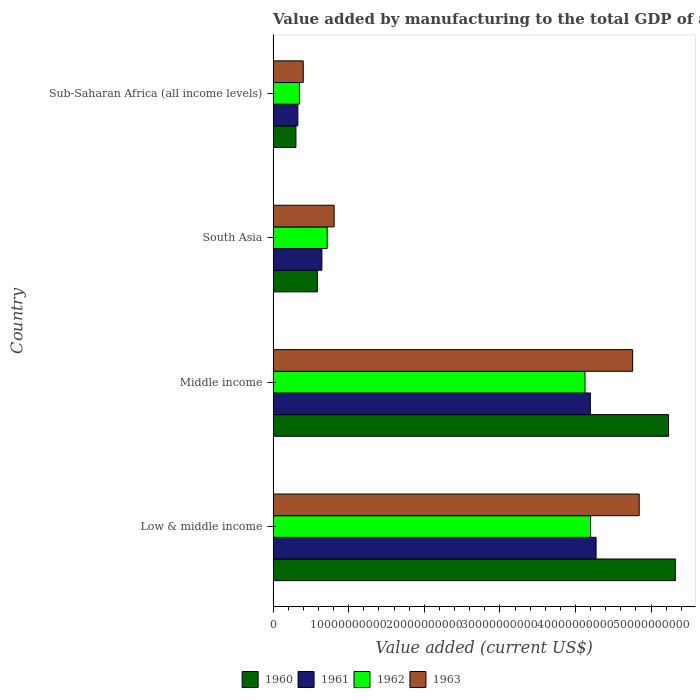How many groups of bars are there?
Offer a very short reply. 4. Are the number of bars on each tick of the Y-axis equal?
Your response must be concise. Yes. How many bars are there on the 4th tick from the bottom?
Your response must be concise. 4. What is the label of the 2nd group of bars from the top?
Your answer should be compact. South Asia. What is the value added by manufacturing to the total GDP in 1962 in Low & middle income?
Give a very brief answer. 4.20e+1. Across all countries, what is the maximum value added by manufacturing to the total GDP in 1961?
Make the answer very short. 4.27e+1. Across all countries, what is the minimum value added by manufacturing to the total GDP in 1962?
Give a very brief answer. 3.48e+09. In which country was the value added by manufacturing to the total GDP in 1960 maximum?
Offer a terse response. Low & middle income. In which country was the value added by manufacturing to the total GDP in 1960 minimum?
Provide a succinct answer. Sub-Saharan Africa (all income levels). What is the total value added by manufacturing to the total GDP in 1962 in the graph?
Provide a short and direct response. 9.39e+1. What is the difference between the value added by manufacturing to the total GDP in 1963 in Low & middle income and that in South Asia?
Your answer should be very brief. 4.04e+1. What is the difference between the value added by manufacturing to the total GDP in 1961 in Middle income and the value added by manufacturing to the total GDP in 1963 in Low & middle income?
Keep it short and to the point. -6.46e+09. What is the average value added by manufacturing to the total GDP in 1962 per country?
Give a very brief answer. 2.35e+1. What is the difference between the value added by manufacturing to the total GDP in 1962 and value added by manufacturing to the total GDP in 1960 in Sub-Saharan Africa (all income levels)?
Ensure brevity in your answer.  4.65e+08. What is the ratio of the value added by manufacturing to the total GDP in 1962 in South Asia to that in Sub-Saharan Africa (all income levels)?
Your answer should be compact. 2.05. Is the value added by manufacturing to the total GDP in 1961 in South Asia less than that in Sub-Saharan Africa (all income levels)?
Make the answer very short. No. What is the difference between the highest and the second highest value added by manufacturing to the total GDP in 1961?
Your answer should be compact. 7.56e+08. What is the difference between the highest and the lowest value added by manufacturing to the total GDP in 1963?
Provide a short and direct response. 4.44e+1. What does the 2nd bar from the top in Low & middle income represents?
Offer a very short reply. 1962. Is it the case that in every country, the sum of the value added by manufacturing to the total GDP in 1960 and value added by manufacturing to the total GDP in 1962 is greater than the value added by manufacturing to the total GDP in 1963?
Provide a succinct answer. Yes. How many bars are there?
Give a very brief answer. 16. Are all the bars in the graph horizontal?
Your answer should be compact. Yes. Where does the legend appear in the graph?
Provide a short and direct response. Bottom center. How are the legend labels stacked?
Your answer should be compact. Horizontal. What is the title of the graph?
Your response must be concise. Value added by manufacturing to the total GDP of a country. Does "1985" appear as one of the legend labels in the graph?
Your answer should be compact. No. What is the label or title of the X-axis?
Give a very brief answer. Value added (current US$). What is the Value added (current US$) in 1960 in Low & middle income?
Offer a very short reply. 5.32e+1. What is the Value added (current US$) in 1961 in Low & middle income?
Provide a short and direct response. 4.27e+1. What is the Value added (current US$) of 1962 in Low & middle income?
Provide a short and direct response. 4.20e+1. What is the Value added (current US$) in 1963 in Low & middle income?
Provide a succinct answer. 4.84e+1. What is the Value added (current US$) of 1960 in Middle income?
Your answer should be compact. 5.23e+1. What is the Value added (current US$) in 1961 in Middle income?
Offer a terse response. 4.20e+1. What is the Value added (current US$) of 1962 in Middle income?
Make the answer very short. 4.13e+1. What is the Value added (current US$) of 1963 in Middle income?
Your answer should be very brief. 4.76e+1. What is the Value added (current US$) in 1960 in South Asia?
Your response must be concise. 5.86e+09. What is the Value added (current US$) of 1961 in South Asia?
Your answer should be compact. 6.45e+09. What is the Value added (current US$) of 1962 in South Asia?
Your response must be concise. 7.15e+09. What is the Value added (current US$) in 1963 in South Asia?
Make the answer very short. 8.07e+09. What is the Value added (current US$) of 1960 in Sub-Saharan Africa (all income levels)?
Your answer should be very brief. 3.02e+09. What is the Value added (current US$) in 1961 in Sub-Saharan Africa (all income levels)?
Keep it short and to the point. 3.27e+09. What is the Value added (current US$) of 1962 in Sub-Saharan Africa (all income levels)?
Provide a succinct answer. 3.48e+09. What is the Value added (current US$) in 1963 in Sub-Saharan Africa (all income levels)?
Offer a very short reply. 3.98e+09. Across all countries, what is the maximum Value added (current US$) of 1960?
Give a very brief answer. 5.32e+1. Across all countries, what is the maximum Value added (current US$) of 1961?
Make the answer very short. 4.27e+1. Across all countries, what is the maximum Value added (current US$) in 1962?
Make the answer very short. 4.20e+1. Across all countries, what is the maximum Value added (current US$) of 1963?
Offer a terse response. 4.84e+1. Across all countries, what is the minimum Value added (current US$) in 1960?
Your answer should be very brief. 3.02e+09. Across all countries, what is the minimum Value added (current US$) of 1961?
Offer a very short reply. 3.27e+09. Across all countries, what is the minimum Value added (current US$) of 1962?
Keep it short and to the point. 3.48e+09. Across all countries, what is the minimum Value added (current US$) of 1963?
Provide a succinct answer. 3.98e+09. What is the total Value added (current US$) of 1960 in the graph?
Offer a terse response. 1.14e+11. What is the total Value added (current US$) of 1961 in the graph?
Provide a short and direct response. 9.44e+1. What is the total Value added (current US$) of 1962 in the graph?
Your answer should be very brief. 9.39e+1. What is the total Value added (current US$) in 1963 in the graph?
Make the answer very short. 1.08e+11. What is the difference between the Value added (current US$) in 1960 in Low & middle income and that in Middle income?
Offer a terse response. 9.04e+08. What is the difference between the Value added (current US$) in 1961 in Low & middle income and that in Middle income?
Your answer should be compact. 7.56e+08. What is the difference between the Value added (current US$) in 1962 in Low & middle income and that in Middle income?
Your answer should be compact. 7.46e+08. What is the difference between the Value added (current US$) in 1963 in Low & middle income and that in Middle income?
Provide a succinct answer. 8.65e+08. What is the difference between the Value added (current US$) of 1960 in Low & middle income and that in South Asia?
Give a very brief answer. 4.74e+1. What is the difference between the Value added (current US$) in 1961 in Low & middle income and that in South Asia?
Ensure brevity in your answer.  3.63e+1. What is the difference between the Value added (current US$) in 1962 in Low & middle income and that in South Asia?
Make the answer very short. 3.49e+1. What is the difference between the Value added (current US$) in 1963 in Low & middle income and that in South Asia?
Provide a short and direct response. 4.04e+1. What is the difference between the Value added (current US$) in 1960 in Low & middle income and that in Sub-Saharan Africa (all income levels)?
Provide a short and direct response. 5.02e+1. What is the difference between the Value added (current US$) in 1961 in Low & middle income and that in Sub-Saharan Africa (all income levels)?
Make the answer very short. 3.95e+1. What is the difference between the Value added (current US$) of 1962 in Low & middle income and that in Sub-Saharan Africa (all income levels)?
Your answer should be compact. 3.85e+1. What is the difference between the Value added (current US$) of 1963 in Low & middle income and that in Sub-Saharan Africa (all income levels)?
Make the answer very short. 4.44e+1. What is the difference between the Value added (current US$) of 1960 in Middle income and that in South Asia?
Your response must be concise. 4.65e+1. What is the difference between the Value added (current US$) in 1961 in Middle income and that in South Asia?
Provide a short and direct response. 3.55e+1. What is the difference between the Value added (current US$) in 1962 in Middle income and that in South Asia?
Offer a very short reply. 3.41e+1. What is the difference between the Value added (current US$) in 1963 in Middle income and that in South Asia?
Your answer should be compact. 3.95e+1. What is the difference between the Value added (current US$) in 1960 in Middle income and that in Sub-Saharan Africa (all income levels)?
Give a very brief answer. 4.93e+1. What is the difference between the Value added (current US$) of 1961 in Middle income and that in Sub-Saharan Africa (all income levels)?
Make the answer very short. 3.87e+1. What is the difference between the Value added (current US$) in 1962 in Middle income and that in Sub-Saharan Africa (all income levels)?
Your answer should be compact. 3.78e+1. What is the difference between the Value added (current US$) of 1963 in Middle income and that in Sub-Saharan Africa (all income levels)?
Ensure brevity in your answer.  4.36e+1. What is the difference between the Value added (current US$) of 1960 in South Asia and that in Sub-Saharan Africa (all income levels)?
Provide a succinct answer. 2.84e+09. What is the difference between the Value added (current US$) in 1961 in South Asia and that in Sub-Saharan Africa (all income levels)?
Offer a very short reply. 3.18e+09. What is the difference between the Value added (current US$) of 1962 in South Asia and that in Sub-Saharan Africa (all income levels)?
Your answer should be very brief. 3.67e+09. What is the difference between the Value added (current US$) of 1963 in South Asia and that in Sub-Saharan Africa (all income levels)?
Your answer should be compact. 4.08e+09. What is the difference between the Value added (current US$) of 1960 in Low & middle income and the Value added (current US$) of 1961 in Middle income?
Provide a short and direct response. 1.12e+1. What is the difference between the Value added (current US$) in 1960 in Low & middle income and the Value added (current US$) in 1962 in Middle income?
Ensure brevity in your answer.  1.20e+1. What is the difference between the Value added (current US$) of 1960 in Low & middle income and the Value added (current US$) of 1963 in Middle income?
Provide a short and direct response. 5.65e+09. What is the difference between the Value added (current US$) of 1961 in Low & middle income and the Value added (current US$) of 1962 in Middle income?
Offer a very short reply. 1.47e+09. What is the difference between the Value added (current US$) of 1961 in Low & middle income and the Value added (current US$) of 1963 in Middle income?
Offer a terse response. -4.84e+09. What is the difference between the Value added (current US$) of 1962 in Low & middle income and the Value added (current US$) of 1963 in Middle income?
Your response must be concise. -5.56e+09. What is the difference between the Value added (current US$) in 1960 in Low & middle income and the Value added (current US$) in 1961 in South Asia?
Offer a very short reply. 4.68e+1. What is the difference between the Value added (current US$) in 1960 in Low & middle income and the Value added (current US$) in 1962 in South Asia?
Make the answer very short. 4.61e+1. What is the difference between the Value added (current US$) in 1960 in Low & middle income and the Value added (current US$) in 1963 in South Asia?
Your answer should be compact. 4.52e+1. What is the difference between the Value added (current US$) of 1961 in Low & middle income and the Value added (current US$) of 1962 in South Asia?
Make the answer very short. 3.56e+1. What is the difference between the Value added (current US$) in 1961 in Low & middle income and the Value added (current US$) in 1963 in South Asia?
Give a very brief answer. 3.47e+1. What is the difference between the Value added (current US$) of 1962 in Low & middle income and the Value added (current US$) of 1963 in South Asia?
Keep it short and to the point. 3.39e+1. What is the difference between the Value added (current US$) in 1960 in Low & middle income and the Value added (current US$) in 1961 in Sub-Saharan Africa (all income levels)?
Your answer should be compact. 4.99e+1. What is the difference between the Value added (current US$) in 1960 in Low & middle income and the Value added (current US$) in 1962 in Sub-Saharan Africa (all income levels)?
Your answer should be compact. 4.97e+1. What is the difference between the Value added (current US$) of 1960 in Low & middle income and the Value added (current US$) of 1963 in Sub-Saharan Africa (all income levels)?
Provide a short and direct response. 4.92e+1. What is the difference between the Value added (current US$) of 1961 in Low & middle income and the Value added (current US$) of 1962 in Sub-Saharan Africa (all income levels)?
Your response must be concise. 3.92e+1. What is the difference between the Value added (current US$) of 1961 in Low & middle income and the Value added (current US$) of 1963 in Sub-Saharan Africa (all income levels)?
Your response must be concise. 3.87e+1. What is the difference between the Value added (current US$) in 1962 in Low & middle income and the Value added (current US$) in 1963 in Sub-Saharan Africa (all income levels)?
Offer a very short reply. 3.80e+1. What is the difference between the Value added (current US$) in 1960 in Middle income and the Value added (current US$) in 1961 in South Asia?
Keep it short and to the point. 4.59e+1. What is the difference between the Value added (current US$) in 1960 in Middle income and the Value added (current US$) in 1962 in South Asia?
Give a very brief answer. 4.52e+1. What is the difference between the Value added (current US$) in 1960 in Middle income and the Value added (current US$) in 1963 in South Asia?
Provide a succinct answer. 4.42e+1. What is the difference between the Value added (current US$) in 1961 in Middle income and the Value added (current US$) in 1962 in South Asia?
Keep it short and to the point. 3.48e+1. What is the difference between the Value added (current US$) of 1961 in Middle income and the Value added (current US$) of 1963 in South Asia?
Ensure brevity in your answer.  3.39e+1. What is the difference between the Value added (current US$) of 1962 in Middle income and the Value added (current US$) of 1963 in South Asia?
Your answer should be very brief. 3.32e+1. What is the difference between the Value added (current US$) in 1960 in Middle income and the Value added (current US$) in 1961 in Sub-Saharan Africa (all income levels)?
Your response must be concise. 4.90e+1. What is the difference between the Value added (current US$) in 1960 in Middle income and the Value added (current US$) in 1962 in Sub-Saharan Africa (all income levels)?
Your answer should be compact. 4.88e+1. What is the difference between the Value added (current US$) of 1960 in Middle income and the Value added (current US$) of 1963 in Sub-Saharan Africa (all income levels)?
Provide a short and direct response. 4.83e+1. What is the difference between the Value added (current US$) in 1961 in Middle income and the Value added (current US$) in 1962 in Sub-Saharan Africa (all income levels)?
Your answer should be compact. 3.85e+1. What is the difference between the Value added (current US$) of 1961 in Middle income and the Value added (current US$) of 1963 in Sub-Saharan Africa (all income levels)?
Ensure brevity in your answer.  3.80e+1. What is the difference between the Value added (current US$) of 1962 in Middle income and the Value added (current US$) of 1963 in Sub-Saharan Africa (all income levels)?
Provide a succinct answer. 3.73e+1. What is the difference between the Value added (current US$) of 1960 in South Asia and the Value added (current US$) of 1961 in Sub-Saharan Africa (all income levels)?
Offer a terse response. 2.58e+09. What is the difference between the Value added (current US$) in 1960 in South Asia and the Value added (current US$) in 1962 in Sub-Saharan Africa (all income levels)?
Offer a terse response. 2.37e+09. What is the difference between the Value added (current US$) of 1960 in South Asia and the Value added (current US$) of 1963 in Sub-Saharan Africa (all income levels)?
Your answer should be compact. 1.87e+09. What is the difference between the Value added (current US$) of 1961 in South Asia and the Value added (current US$) of 1962 in Sub-Saharan Africa (all income levels)?
Your response must be concise. 2.97e+09. What is the difference between the Value added (current US$) in 1961 in South Asia and the Value added (current US$) in 1963 in Sub-Saharan Africa (all income levels)?
Make the answer very short. 2.47e+09. What is the difference between the Value added (current US$) in 1962 in South Asia and the Value added (current US$) in 1963 in Sub-Saharan Africa (all income levels)?
Provide a short and direct response. 3.17e+09. What is the average Value added (current US$) of 1960 per country?
Give a very brief answer. 2.86e+1. What is the average Value added (current US$) of 1961 per country?
Your answer should be compact. 2.36e+1. What is the average Value added (current US$) of 1962 per country?
Ensure brevity in your answer.  2.35e+1. What is the average Value added (current US$) of 1963 per country?
Your response must be concise. 2.70e+1. What is the difference between the Value added (current US$) of 1960 and Value added (current US$) of 1961 in Low & middle income?
Offer a very short reply. 1.05e+1. What is the difference between the Value added (current US$) of 1960 and Value added (current US$) of 1962 in Low & middle income?
Offer a very short reply. 1.12e+1. What is the difference between the Value added (current US$) in 1960 and Value added (current US$) in 1963 in Low & middle income?
Provide a succinct answer. 4.79e+09. What is the difference between the Value added (current US$) in 1961 and Value added (current US$) in 1962 in Low & middle income?
Ensure brevity in your answer.  7.22e+08. What is the difference between the Value added (current US$) of 1961 and Value added (current US$) of 1963 in Low & middle income?
Make the answer very short. -5.70e+09. What is the difference between the Value added (current US$) in 1962 and Value added (current US$) in 1963 in Low & middle income?
Make the answer very short. -6.43e+09. What is the difference between the Value added (current US$) in 1960 and Value added (current US$) in 1961 in Middle income?
Provide a short and direct response. 1.03e+1. What is the difference between the Value added (current US$) of 1960 and Value added (current US$) of 1962 in Middle income?
Provide a short and direct response. 1.11e+1. What is the difference between the Value added (current US$) in 1960 and Value added (current US$) in 1963 in Middle income?
Your answer should be very brief. 4.75e+09. What is the difference between the Value added (current US$) of 1961 and Value added (current US$) of 1962 in Middle income?
Your response must be concise. 7.12e+08. What is the difference between the Value added (current US$) in 1961 and Value added (current US$) in 1963 in Middle income?
Offer a very short reply. -5.59e+09. What is the difference between the Value added (current US$) of 1962 and Value added (current US$) of 1963 in Middle income?
Provide a succinct answer. -6.31e+09. What is the difference between the Value added (current US$) of 1960 and Value added (current US$) of 1961 in South Asia?
Provide a succinct answer. -5.98e+08. What is the difference between the Value added (current US$) of 1960 and Value added (current US$) of 1962 in South Asia?
Keep it short and to the point. -1.30e+09. What is the difference between the Value added (current US$) in 1960 and Value added (current US$) in 1963 in South Asia?
Offer a very short reply. -2.21e+09. What is the difference between the Value added (current US$) in 1961 and Value added (current US$) in 1962 in South Asia?
Ensure brevity in your answer.  -6.98e+08. What is the difference between the Value added (current US$) in 1961 and Value added (current US$) in 1963 in South Asia?
Give a very brief answer. -1.61e+09. What is the difference between the Value added (current US$) in 1962 and Value added (current US$) in 1963 in South Asia?
Offer a terse response. -9.17e+08. What is the difference between the Value added (current US$) of 1960 and Value added (current US$) of 1961 in Sub-Saharan Africa (all income levels)?
Your answer should be very brief. -2.55e+08. What is the difference between the Value added (current US$) of 1960 and Value added (current US$) of 1962 in Sub-Saharan Africa (all income levels)?
Provide a short and direct response. -4.65e+08. What is the difference between the Value added (current US$) of 1960 and Value added (current US$) of 1963 in Sub-Saharan Africa (all income levels)?
Give a very brief answer. -9.68e+08. What is the difference between the Value added (current US$) in 1961 and Value added (current US$) in 1962 in Sub-Saharan Africa (all income levels)?
Your answer should be compact. -2.09e+08. What is the difference between the Value added (current US$) in 1961 and Value added (current US$) in 1963 in Sub-Saharan Africa (all income levels)?
Provide a short and direct response. -7.12e+08. What is the difference between the Value added (current US$) of 1962 and Value added (current US$) of 1963 in Sub-Saharan Africa (all income levels)?
Make the answer very short. -5.03e+08. What is the ratio of the Value added (current US$) in 1960 in Low & middle income to that in Middle income?
Your response must be concise. 1.02. What is the ratio of the Value added (current US$) in 1962 in Low & middle income to that in Middle income?
Offer a terse response. 1.02. What is the ratio of the Value added (current US$) of 1963 in Low & middle income to that in Middle income?
Provide a succinct answer. 1.02. What is the ratio of the Value added (current US$) in 1960 in Low & middle income to that in South Asia?
Offer a very short reply. 9.09. What is the ratio of the Value added (current US$) in 1961 in Low & middle income to that in South Asia?
Your answer should be compact. 6.62. What is the ratio of the Value added (current US$) in 1962 in Low & middle income to that in South Asia?
Offer a very short reply. 5.87. What is the ratio of the Value added (current US$) in 1963 in Low & middle income to that in South Asia?
Your response must be concise. 6. What is the ratio of the Value added (current US$) of 1960 in Low & middle income to that in Sub-Saharan Africa (all income levels)?
Keep it short and to the point. 17.65. What is the ratio of the Value added (current US$) in 1961 in Low & middle income to that in Sub-Saharan Africa (all income levels)?
Your answer should be very brief. 13.06. What is the ratio of the Value added (current US$) of 1962 in Low & middle income to that in Sub-Saharan Africa (all income levels)?
Offer a very short reply. 12.07. What is the ratio of the Value added (current US$) in 1963 in Low & middle income to that in Sub-Saharan Africa (all income levels)?
Offer a very short reply. 12.16. What is the ratio of the Value added (current US$) in 1960 in Middle income to that in South Asia?
Provide a succinct answer. 8.93. What is the ratio of the Value added (current US$) of 1961 in Middle income to that in South Asia?
Ensure brevity in your answer.  6.5. What is the ratio of the Value added (current US$) of 1962 in Middle income to that in South Asia?
Give a very brief answer. 5.77. What is the ratio of the Value added (current US$) of 1963 in Middle income to that in South Asia?
Offer a very short reply. 5.9. What is the ratio of the Value added (current US$) in 1960 in Middle income to that in Sub-Saharan Africa (all income levels)?
Provide a short and direct response. 17.35. What is the ratio of the Value added (current US$) in 1961 in Middle income to that in Sub-Saharan Africa (all income levels)?
Your answer should be very brief. 12.83. What is the ratio of the Value added (current US$) in 1962 in Middle income to that in Sub-Saharan Africa (all income levels)?
Provide a succinct answer. 11.85. What is the ratio of the Value added (current US$) in 1963 in Middle income to that in Sub-Saharan Africa (all income levels)?
Provide a succinct answer. 11.94. What is the ratio of the Value added (current US$) in 1960 in South Asia to that in Sub-Saharan Africa (all income levels)?
Provide a short and direct response. 1.94. What is the ratio of the Value added (current US$) of 1961 in South Asia to that in Sub-Saharan Africa (all income levels)?
Give a very brief answer. 1.97. What is the ratio of the Value added (current US$) of 1962 in South Asia to that in Sub-Saharan Africa (all income levels)?
Give a very brief answer. 2.05. What is the ratio of the Value added (current US$) in 1963 in South Asia to that in Sub-Saharan Africa (all income levels)?
Your response must be concise. 2.03. What is the difference between the highest and the second highest Value added (current US$) in 1960?
Provide a short and direct response. 9.04e+08. What is the difference between the highest and the second highest Value added (current US$) in 1961?
Your response must be concise. 7.56e+08. What is the difference between the highest and the second highest Value added (current US$) in 1962?
Make the answer very short. 7.46e+08. What is the difference between the highest and the second highest Value added (current US$) of 1963?
Give a very brief answer. 8.65e+08. What is the difference between the highest and the lowest Value added (current US$) in 1960?
Ensure brevity in your answer.  5.02e+1. What is the difference between the highest and the lowest Value added (current US$) of 1961?
Keep it short and to the point. 3.95e+1. What is the difference between the highest and the lowest Value added (current US$) of 1962?
Provide a succinct answer. 3.85e+1. What is the difference between the highest and the lowest Value added (current US$) of 1963?
Your response must be concise. 4.44e+1. 